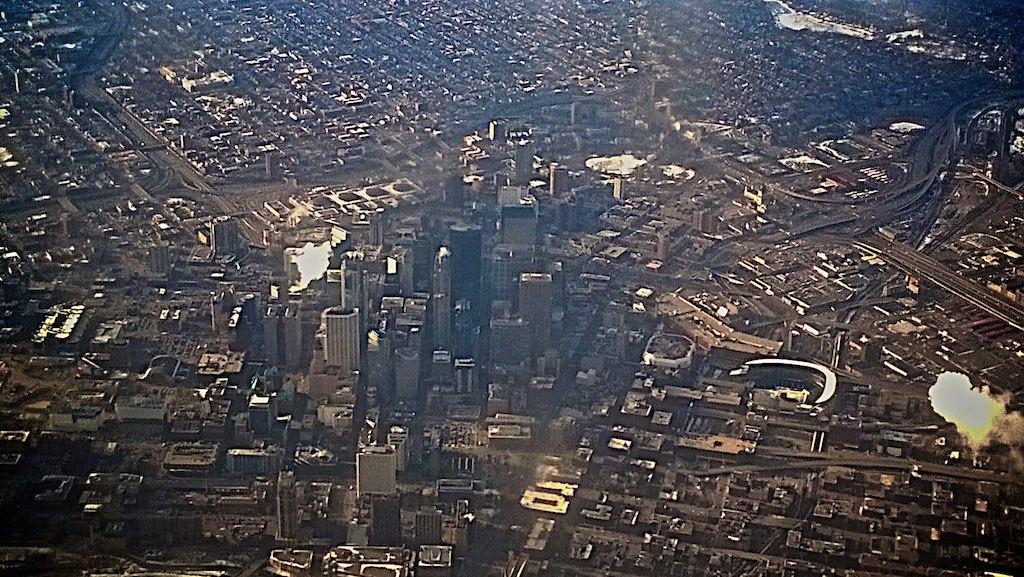What type of location is depicted in the image? The image depicts a city. What are some of the tallest structures in the city? There are skyscrapers in the city. What types of buildings can be seen in the city? There are buildings in the city. What is a feature of the city that allows for transportation? There is a road in the city. What types of vehicles can be seen in the city? There are vehicles in the city. What type of industrial building can be seen in the city? There is a factory in the city. What is happening at the factory in the image? Fire and smoke are coming from the factory. What type of instrument is being played by the lumber in the image? There is no lumber or instrument present in the image. What type of pie is being served at the factory in the image? There is no pie present in the image, and the factory is on fire, not serving food. 